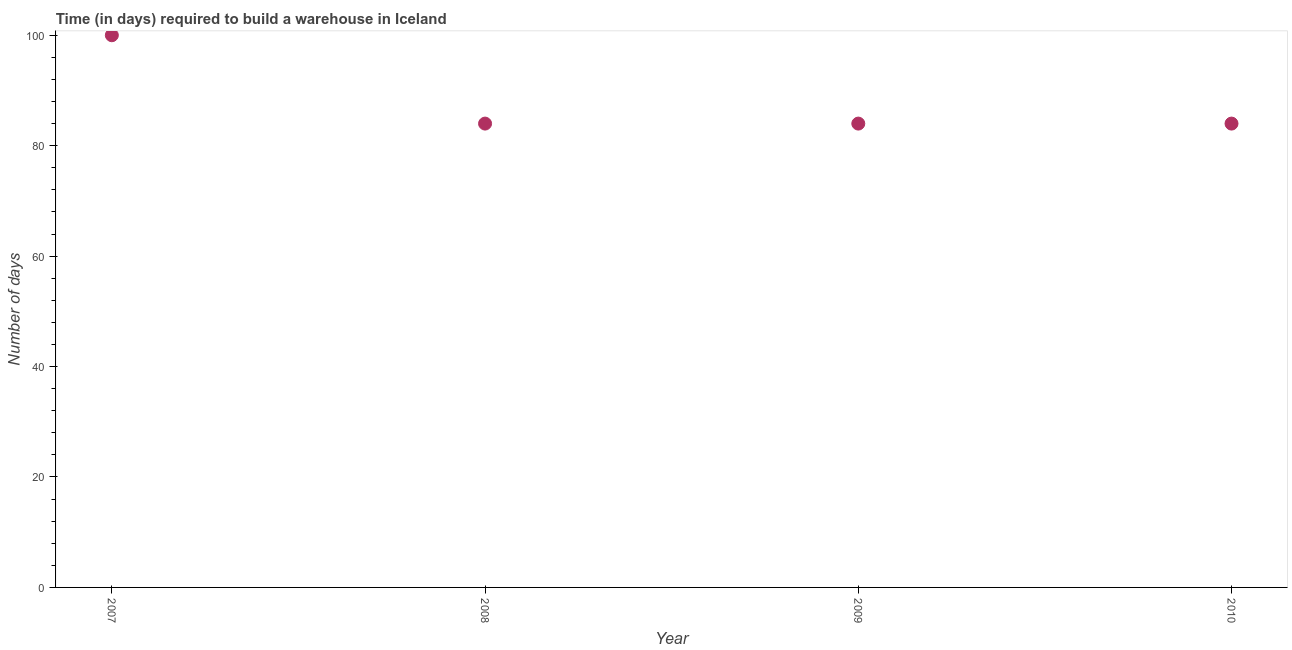What is the time required to build a warehouse in 2008?
Your response must be concise. 84. Across all years, what is the maximum time required to build a warehouse?
Your answer should be compact. 100. Across all years, what is the minimum time required to build a warehouse?
Offer a very short reply. 84. In which year was the time required to build a warehouse minimum?
Make the answer very short. 2008. What is the sum of the time required to build a warehouse?
Your answer should be very brief. 352. What is the difference between the time required to build a warehouse in 2007 and 2010?
Offer a very short reply. 16. What is the median time required to build a warehouse?
Your answer should be compact. 84. In how many years, is the time required to build a warehouse greater than 52 days?
Provide a short and direct response. 4. Is the time required to build a warehouse in 2009 less than that in 2010?
Offer a terse response. No. Is the difference between the time required to build a warehouse in 2008 and 2009 greater than the difference between any two years?
Provide a succinct answer. No. What is the difference between the highest and the lowest time required to build a warehouse?
Your answer should be compact. 16. In how many years, is the time required to build a warehouse greater than the average time required to build a warehouse taken over all years?
Your response must be concise. 1. Does the time required to build a warehouse monotonically increase over the years?
Keep it short and to the point. No. What is the difference between two consecutive major ticks on the Y-axis?
Give a very brief answer. 20. Does the graph contain any zero values?
Provide a succinct answer. No. What is the title of the graph?
Keep it short and to the point. Time (in days) required to build a warehouse in Iceland. What is the label or title of the X-axis?
Give a very brief answer. Year. What is the label or title of the Y-axis?
Ensure brevity in your answer.  Number of days. What is the Number of days in 2009?
Offer a very short reply. 84. What is the Number of days in 2010?
Offer a terse response. 84. What is the difference between the Number of days in 2007 and 2008?
Give a very brief answer. 16. What is the difference between the Number of days in 2007 and 2009?
Give a very brief answer. 16. What is the difference between the Number of days in 2007 and 2010?
Give a very brief answer. 16. What is the ratio of the Number of days in 2007 to that in 2008?
Give a very brief answer. 1.19. What is the ratio of the Number of days in 2007 to that in 2009?
Offer a very short reply. 1.19. What is the ratio of the Number of days in 2007 to that in 2010?
Provide a succinct answer. 1.19. What is the ratio of the Number of days in 2008 to that in 2010?
Ensure brevity in your answer.  1. 